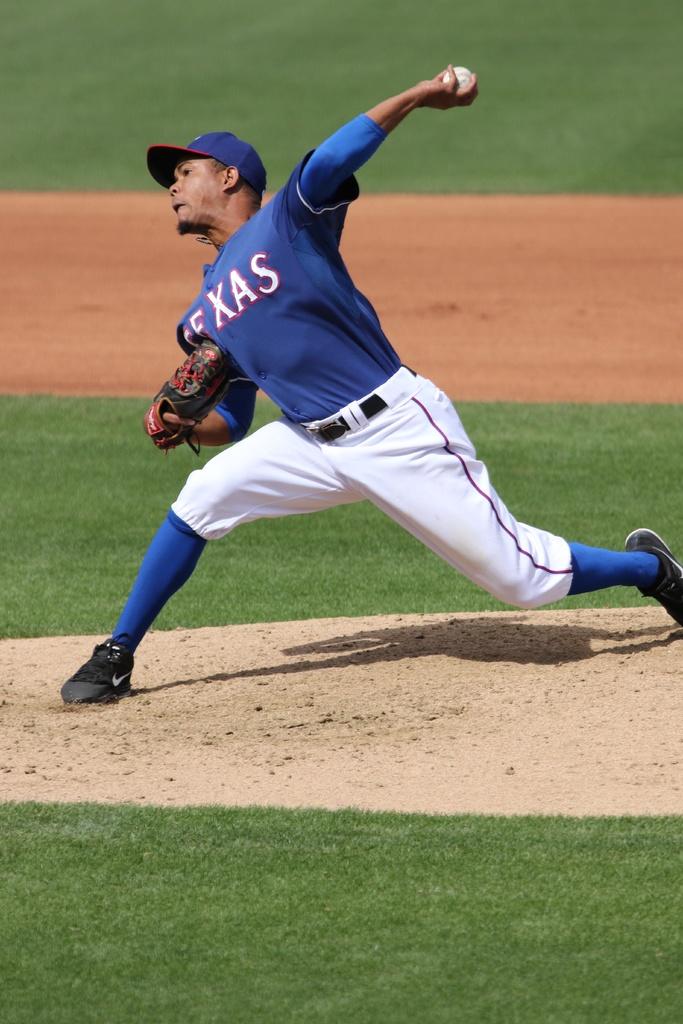What team does the pitcher play for?
Your answer should be very brief. Texas. 